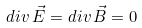<formula> <loc_0><loc_0><loc_500><loc_500>d i v \, \vec { E } = d i v \, \vec { B } = 0</formula> 